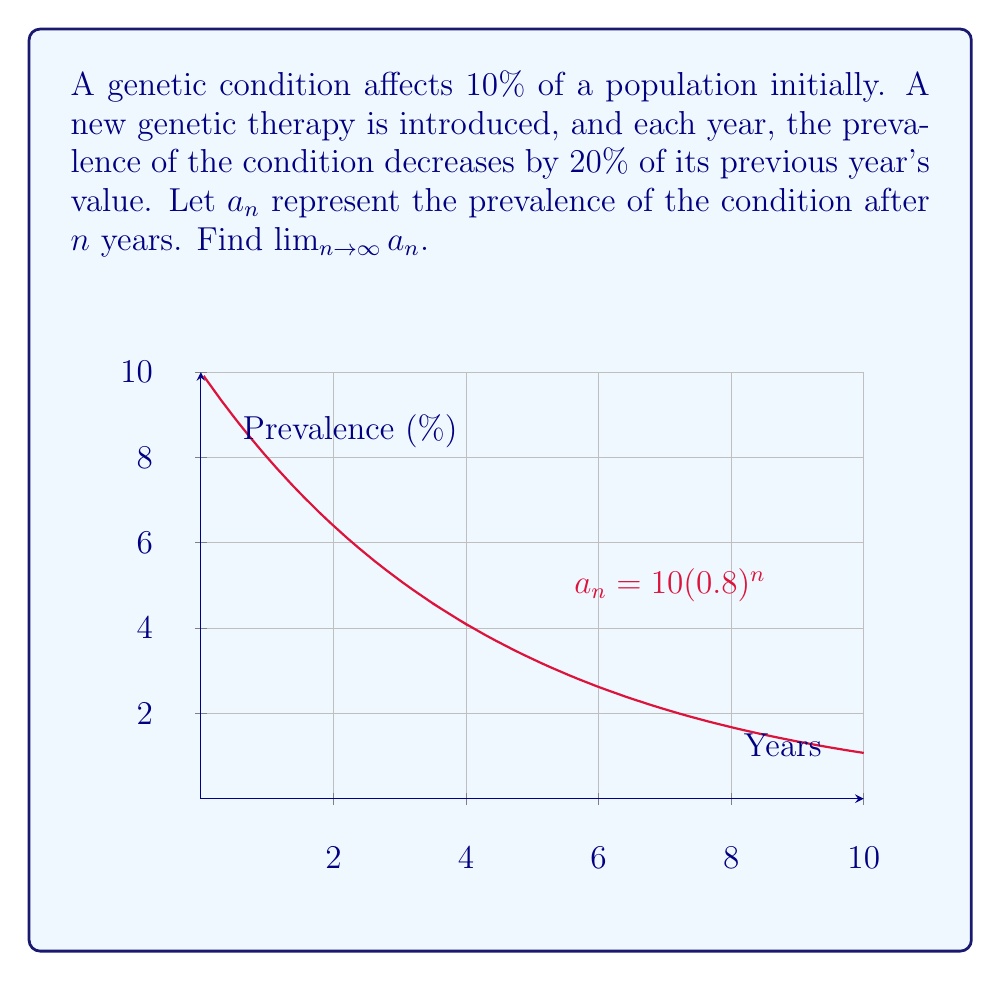Can you solve this math problem? Let's approach this step-by-step:

1) First, we need to express $a_n$ as a function of $n$:
   $a_n = 10 \cdot (0.8)^n$

   This is because the initial prevalence is 10%, and each year it decreases by 20% (or multiplied by 0.8).

2) To find the limit as $n$ approaches infinity, we need to consider the behavior of $(0.8)^n$ as $n$ gets very large.

3) Since $0 < 0.8 < 1$, we know that $(0.8)^n$ approaches 0 as $n$ approaches infinity.

4) Therefore:

   $\lim_{n \to \infty} a_n = \lim_{n \to \infty} 10 \cdot (0.8)^n = 10 \cdot \lim_{n \to \infty} (0.8)^n = 10 \cdot 0 = 0$

5) It's important to note that while mathematically the limit approaches 0, in reality, genetic conditions can't be completely eliminated from a population. This mathematical model simplifies a complex biological reality.
Answer: $0$ 